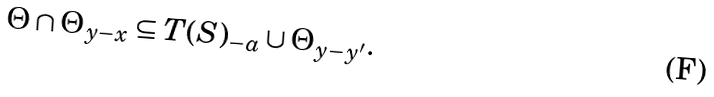<formula> <loc_0><loc_0><loc_500><loc_500>\Theta \cap \Theta _ { y - x } \subseteq T ( S ) _ { - a } \cup \Theta _ { y - y ^ { \prime } } .</formula> 